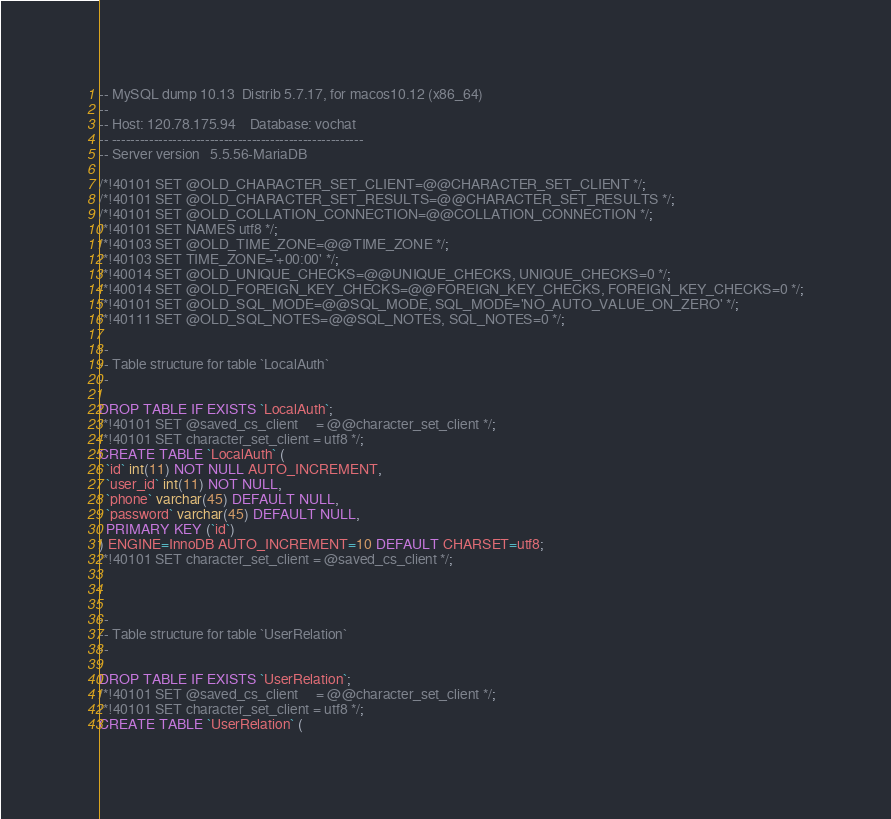Convert code to text. <code><loc_0><loc_0><loc_500><loc_500><_SQL_>-- MySQL dump 10.13  Distrib 5.7.17, for macos10.12 (x86_64)
--
-- Host: 120.78.175.94    Database: vochat
-- ------------------------------------------------------
-- Server version	5.5.56-MariaDB

/*!40101 SET @OLD_CHARACTER_SET_CLIENT=@@CHARACTER_SET_CLIENT */;
/*!40101 SET @OLD_CHARACTER_SET_RESULTS=@@CHARACTER_SET_RESULTS */;
/*!40101 SET @OLD_COLLATION_CONNECTION=@@COLLATION_CONNECTION */;
/*!40101 SET NAMES utf8 */;
/*!40103 SET @OLD_TIME_ZONE=@@TIME_ZONE */;
/*!40103 SET TIME_ZONE='+00:00' */;
/*!40014 SET @OLD_UNIQUE_CHECKS=@@UNIQUE_CHECKS, UNIQUE_CHECKS=0 */;
/*!40014 SET @OLD_FOREIGN_KEY_CHECKS=@@FOREIGN_KEY_CHECKS, FOREIGN_KEY_CHECKS=0 */;
/*!40101 SET @OLD_SQL_MODE=@@SQL_MODE, SQL_MODE='NO_AUTO_VALUE_ON_ZERO' */;
/*!40111 SET @OLD_SQL_NOTES=@@SQL_NOTES, SQL_NOTES=0 */;

--
-- Table structure for table `LocalAuth`
--

DROP TABLE IF EXISTS `LocalAuth`;
/*!40101 SET @saved_cs_client     = @@character_set_client */;
/*!40101 SET character_set_client = utf8 */;
CREATE TABLE `LocalAuth` (
  `id` int(11) NOT NULL AUTO_INCREMENT,
  `user_id` int(11) NOT NULL,
  `phone` varchar(45) DEFAULT NULL,
  `password` varchar(45) DEFAULT NULL,
  PRIMARY KEY (`id`)
) ENGINE=InnoDB AUTO_INCREMENT=10 DEFAULT CHARSET=utf8;
/*!40101 SET character_set_client = @saved_cs_client */;



--
-- Table structure for table `UserRelation`
--

DROP TABLE IF EXISTS `UserRelation`;
/*!40101 SET @saved_cs_client     = @@character_set_client */;
/*!40101 SET character_set_client = utf8 */;
CREATE TABLE `UserRelation` (</code> 